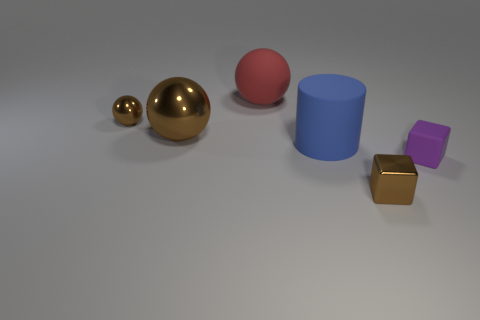Add 1 large red spheres. How many objects exist? 7 Subtract all cylinders. How many objects are left? 5 Add 3 tiny yellow balls. How many tiny yellow balls exist? 3 Subtract 0 brown cylinders. How many objects are left? 6 Subtract all tiny cyan rubber cylinders. Subtract all blue cylinders. How many objects are left? 5 Add 4 blue cylinders. How many blue cylinders are left? 5 